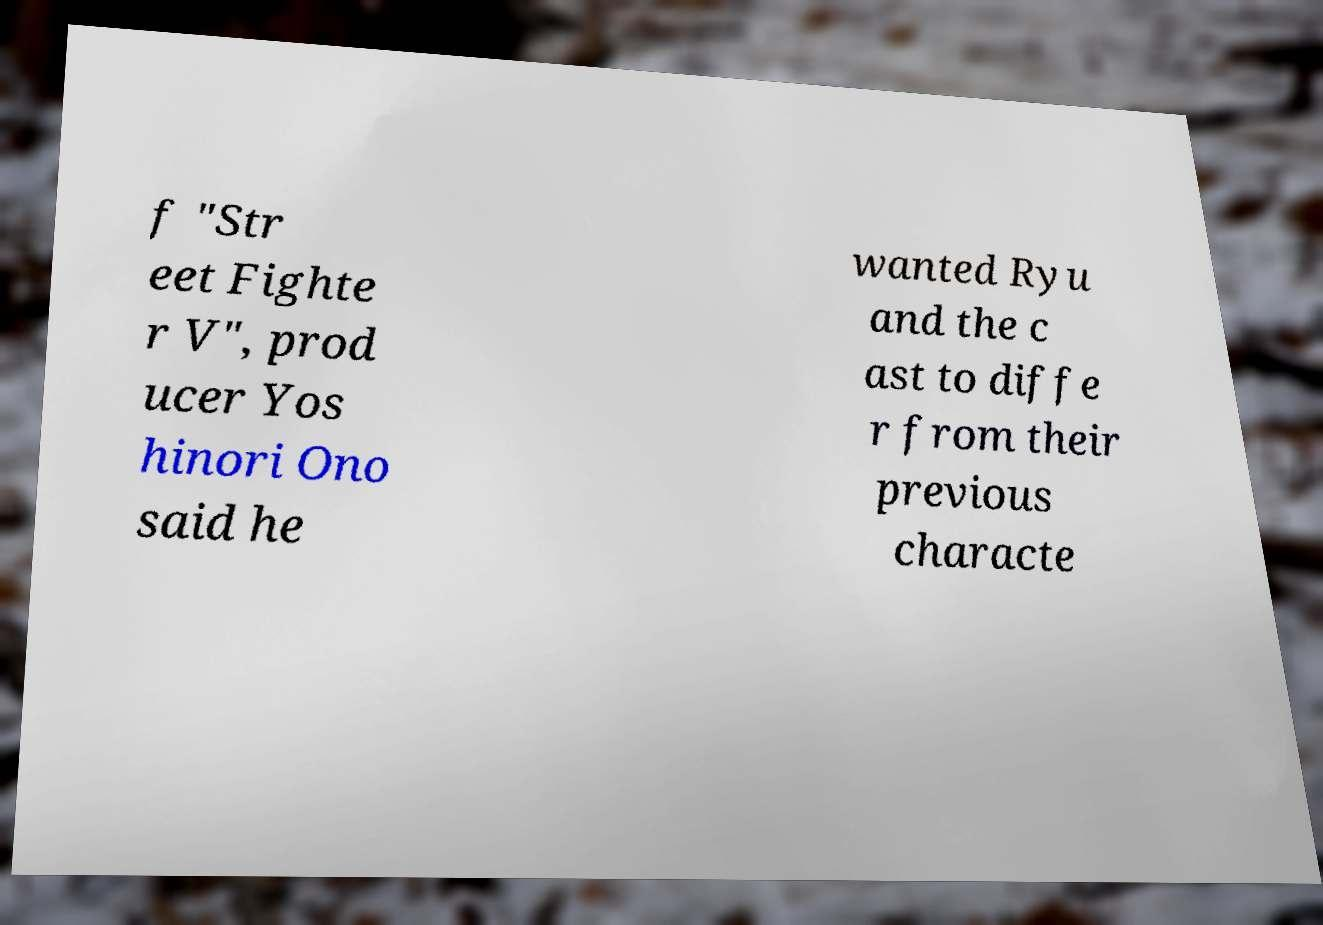Can you accurately transcribe the text from the provided image for me? f "Str eet Fighte r V", prod ucer Yos hinori Ono said he wanted Ryu and the c ast to diffe r from their previous characte 